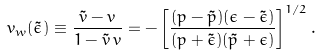<formula> <loc_0><loc_0><loc_500><loc_500>v _ { w } ( \tilde { \epsilon } ) \equiv \frac { \tilde { v } - v } { 1 - \tilde { v } \, v } = - \left [ \frac { ( p - \tilde { p } ) ( \epsilon - \tilde { \epsilon } ) } { ( p + \tilde { \epsilon } ) ( \tilde { p } + \epsilon ) } \right ] ^ { 1 / 2 } .</formula> 